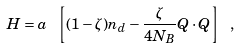<formula> <loc_0><loc_0><loc_500><loc_500>H = a \ \left [ ( 1 - \zeta ) n _ { d } - \frac { \zeta } { 4 N _ { B } } Q \cdot Q \right ] \ ,</formula> 